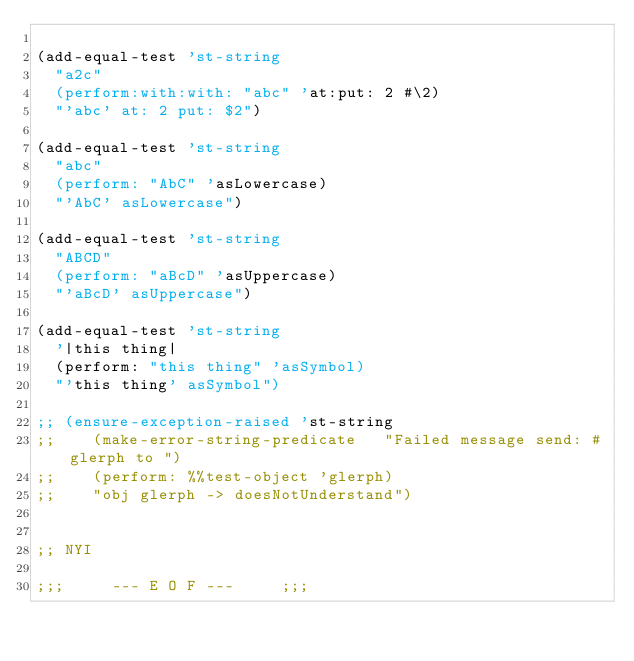Convert code to text. <code><loc_0><loc_0><loc_500><loc_500><_Scheme_>
(add-equal-test 'st-string
  "a2c"
  (perform:with:with: "abc" 'at:put: 2 #\2)
  "'abc' at: 2 put: $2")

(add-equal-test 'st-string
  "abc"
  (perform: "AbC" 'asLowercase)
  "'AbC' asLowercase")

(add-equal-test 'st-string
  "ABCD"
  (perform: "aBcD" 'asUppercase)
  "'aBcD' asUppercase")

(add-equal-test 'st-string
  '|this thing|
  (perform: "this thing" 'asSymbol)
  "'this thing' asSymbol")

;; (ensure-exception-raised 'st-string
;;    (make-error-string-predicate   "Failed message send: #glerph to ")
;;    (perform: %%test-object 'glerph)
;;    "obj glerph -> doesNotUnderstand")


;; NYI

;;;			--- E O F ---			;;;
</code> 